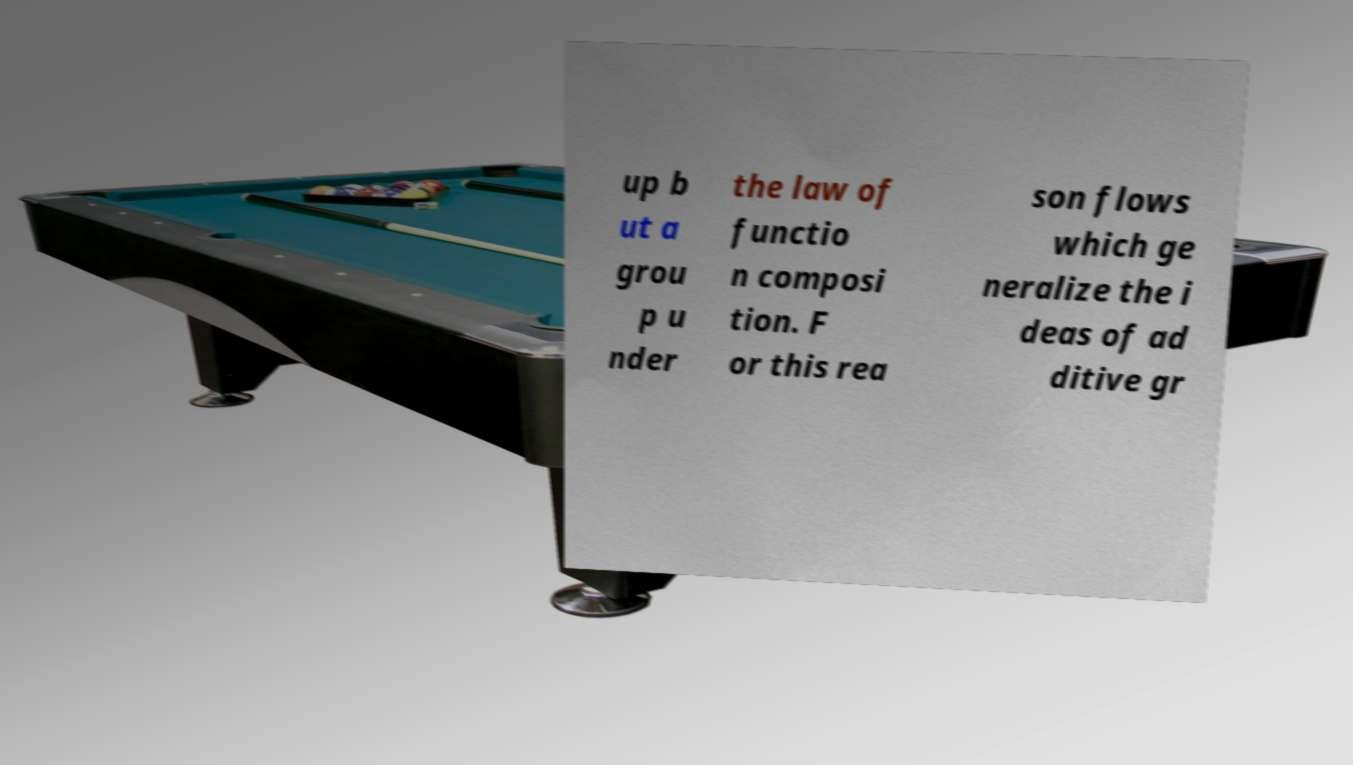What messages or text are displayed in this image? I need them in a readable, typed format. up b ut a grou p u nder the law of functio n composi tion. F or this rea son flows which ge neralize the i deas of ad ditive gr 